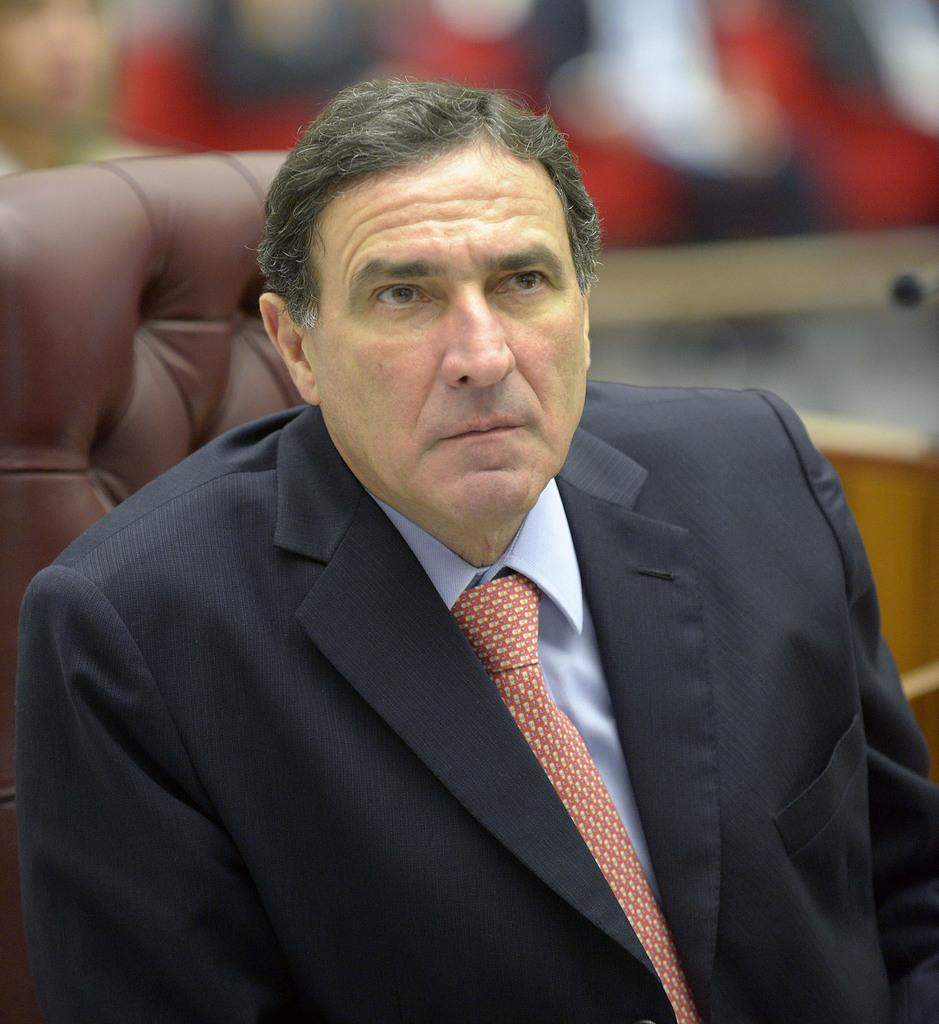Who is present in the image? There is a man in the image. What is the man wearing? The man is wearing a blue blazer. What is the man doing in the image? The man is sitting on a chair. Can you describe the chair behind the man? There is another chair visible behind the man. What can be seen in the background of the image? There are people in the background of the image, and the image is blurred. What type of lumber is being used to construct the door in the image? There is no door present in the image, so it is not possible to determine the type of lumber being used. What scent can be detected in the image? There is no information about scents in the image, so it cannot be determined. 